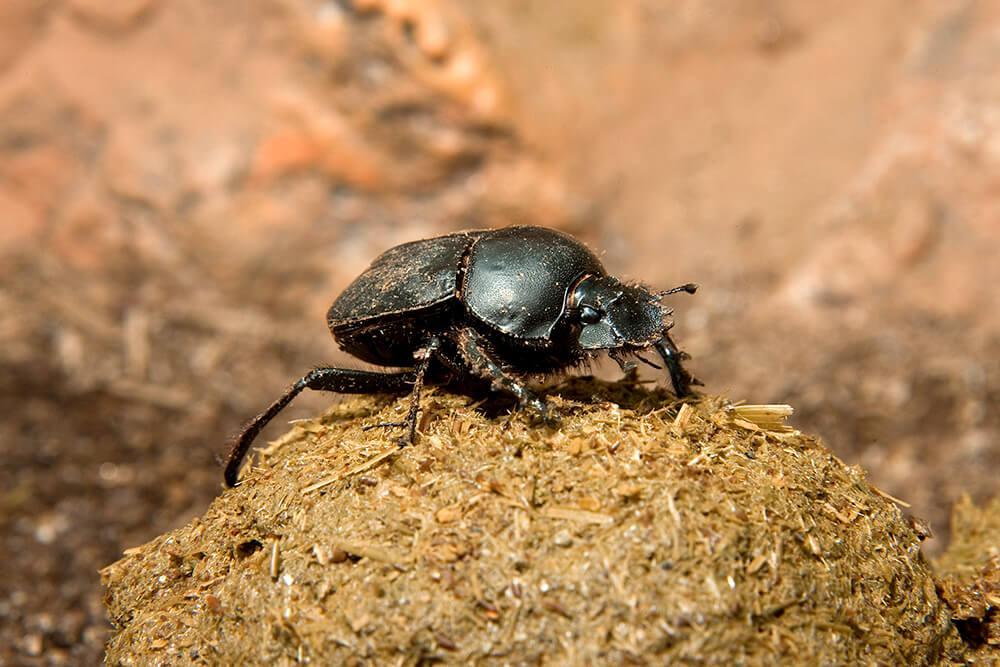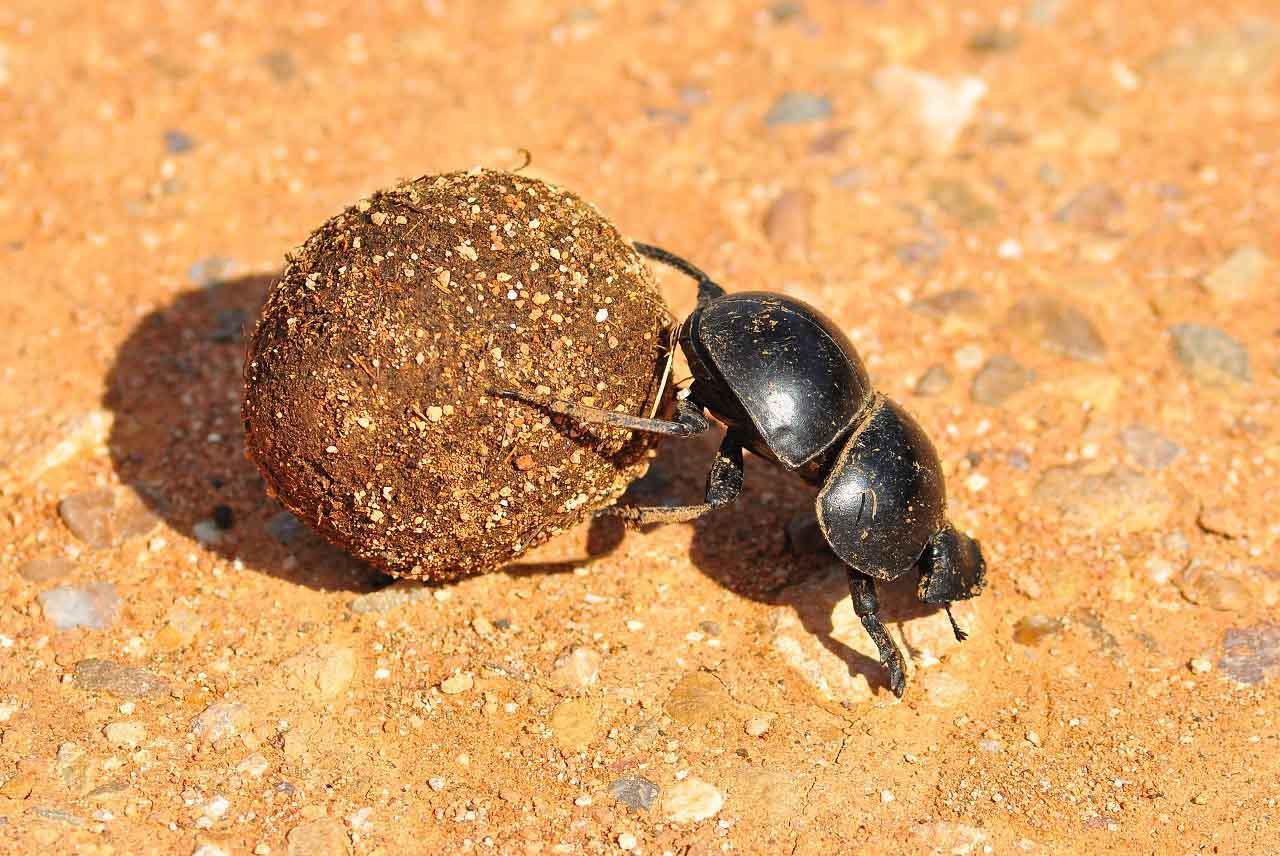The first image is the image on the left, the second image is the image on the right. For the images displayed, is the sentence "There is a beetle that is not in contact with a ball in one image." factually correct? Answer yes or no. No. 